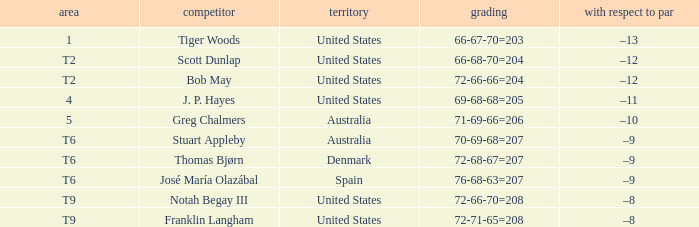What is the place of the player with a 66-68-70=204 score? T2. 